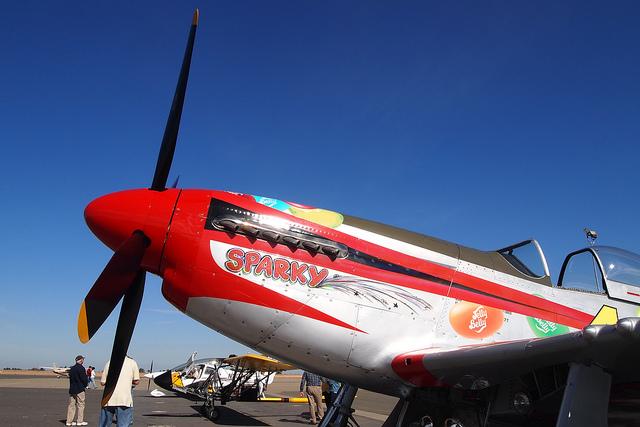Is this a jet?
Write a very short answer. No. What color is the propeller?
Be succinct. Black. What is the name of the plane?
Give a very brief answer. Sparky. 